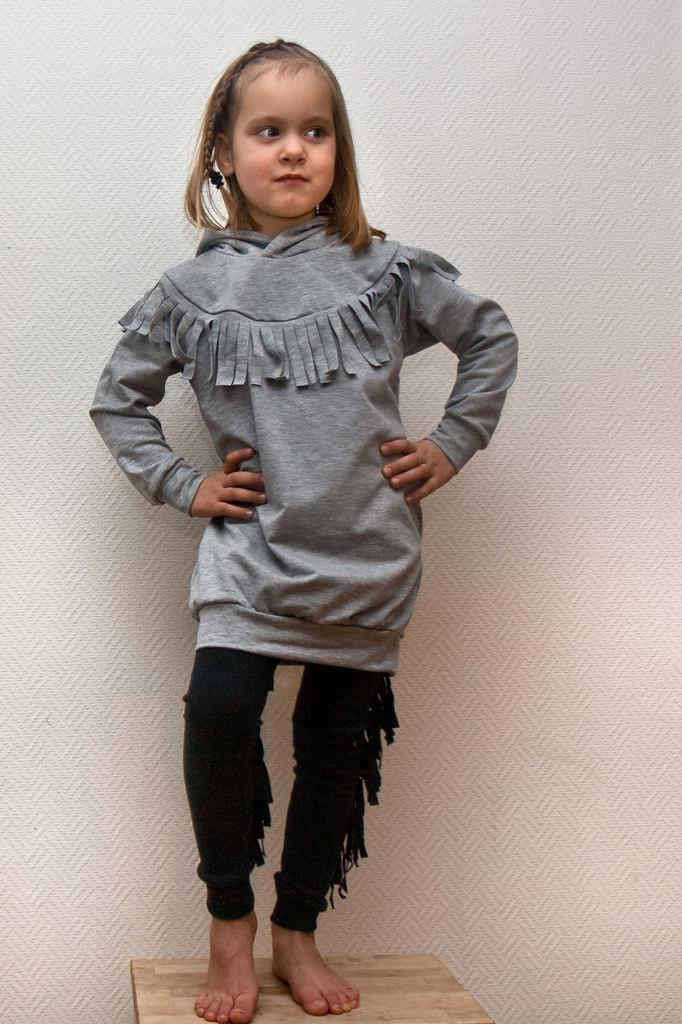Who is the main subject in the image? There is a girl in the image. What is the girl wearing? The girl is wearing a gray t-shirt. What is the girl standing on in the image? The girl is standing on a wooden stool. What is the color of the background in the image? The background of the image is white in color. What type of worm can be seen playing the guitar in the image? There is no worm or guitar present in the image; it features a girl standing on a wooden stool. What type of leather material is visible in the image? There is no leather material visible in the image. 